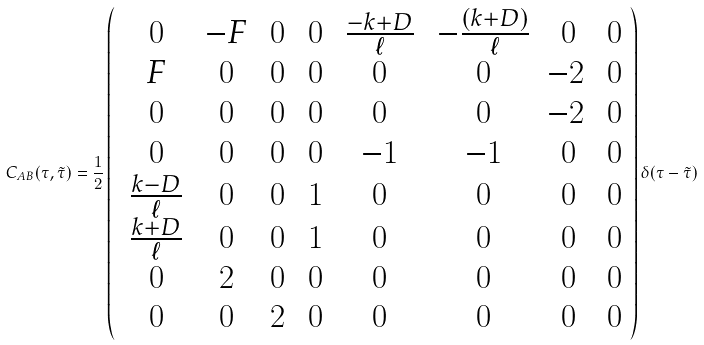<formula> <loc_0><loc_0><loc_500><loc_500>C _ { A B } ( \tau , \tilde { \tau } ) = \frac { 1 } { 2 } \left ( \begin{array} { c c c c c c c c } \, 0 & \, - F & \, 0 & \, 0 & \, \frac { - k + D } { \ell } & \, - \frac { ( k + D ) } { \ell } & \, 0 & \, 0 \\ \, F & \, 0 & \, 0 & \, 0 & \, 0 & \, 0 & - 2 & \, 0 \\ \, 0 & \, 0 & \, 0 & \, 0 & \, 0 & \, 0 & - 2 & \, 0 \\ \, 0 & \, 0 & \, 0 & \, 0 & \, - 1 & \, - 1 & \, 0 & \, 0 \\ \, \frac { k - D } { \ell } & \, 0 & \, 0 & \, 1 & \, 0 & \, 0 & \, 0 & \, 0 \\ \, \frac { k + D } { \ell } & \, 0 & \, 0 & \, 1 & \, 0 & \, 0 & \, 0 & \, 0 \\ \, 0 & \, 2 & \, 0 & \, 0 & \, 0 & \, 0 & \, 0 & \, 0 \\ \, 0 & \, 0 & \, 2 & \, 0 & \, 0 & \, 0 & \, 0 & \, 0 \end{array} \right ) \delta ( \tau - \tilde { \tau } )</formula> 